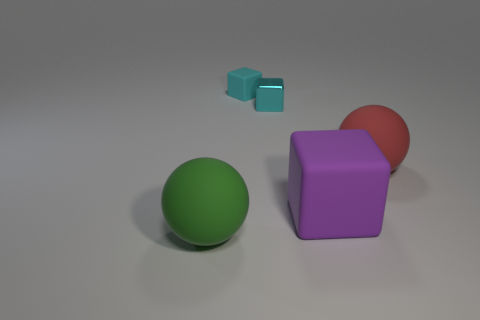Subtract all large purple rubber cubes. How many cubes are left? 2 Subtract all yellow cylinders. How many cyan blocks are left? 2 Subtract all purple cubes. How many cubes are left? 2 Add 3 rubber things. How many objects exist? 8 Subtract all spheres. How many objects are left? 3 Subtract 1 cubes. How many cubes are left? 2 Add 2 large green matte balls. How many large green matte balls are left? 3 Add 5 large rubber things. How many large rubber things exist? 8 Subtract 0 red cylinders. How many objects are left? 5 Subtract all cyan cubes. Subtract all yellow cylinders. How many cubes are left? 1 